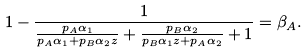<formula> <loc_0><loc_0><loc_500><loc_500>1 - \frac { 1 } { \frac { p _ { A } \alpha _ { 1 } } { p _ { A } \alpha _ { 1 } + p _ { B } \alpha _ { 2 } z } + \frac { p _ { B } \alpha _ { 2 } } { p _ { B } \alpha _ { 1 } z + p _ { A } \alpha _ { 2 } } + 1 } = \beta _ { A } .</formula> 